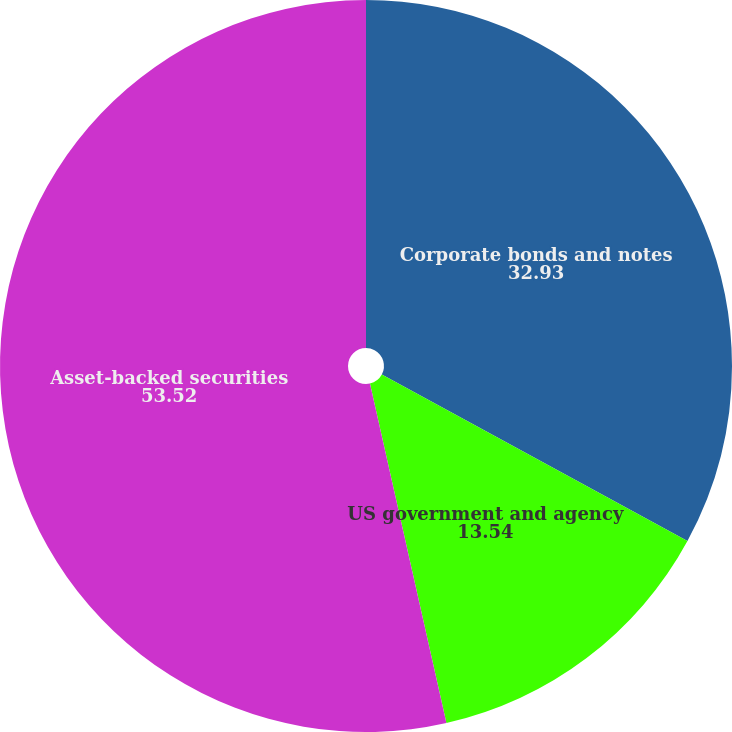Convert chart. <chart><loc_0><loc_0><loc_500><loc_500><pie_chart><fcel>Corporate bonds and notes<fcel>US government and agency<fcel>Asset-backed securities<nl><fcel>32.93%<fcel>13.54%<fcel>53.52%<nl></chart> 